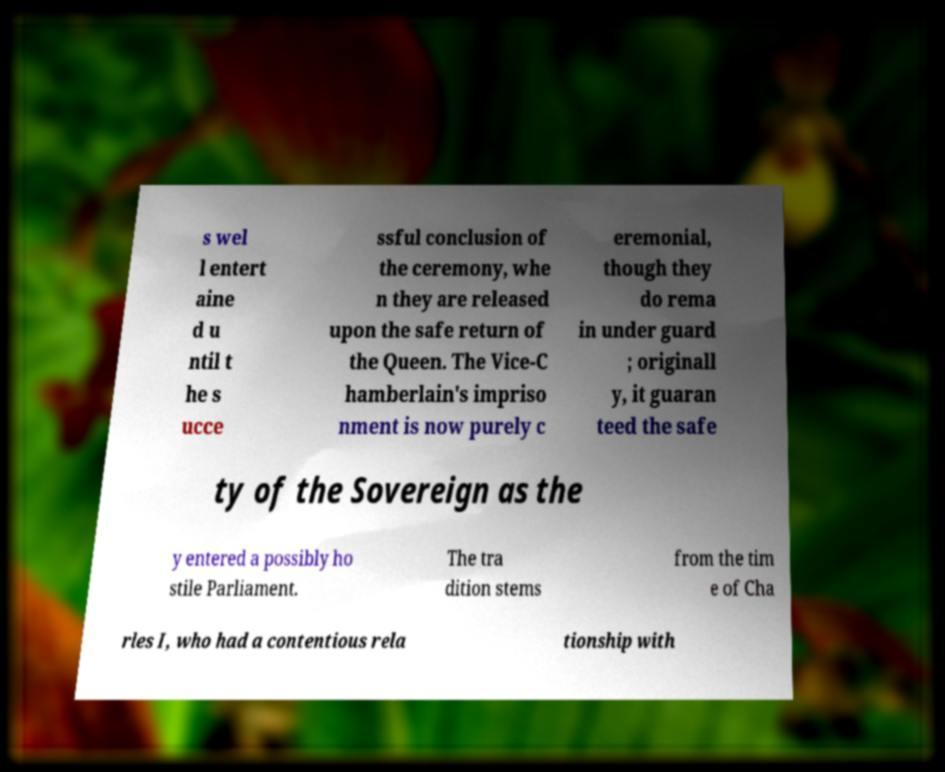What messages or text are displayed in this image? I need them in a readable, typed format. s wel l entert aine d u ntil t he s ucce ssful conclusion of the ceremony, whe n they are released upon the safe return of the Queen. The Vice-C hamberlain's impriso nment is now purely c eremonial, though they do rema in under guard ; originall y, it guaran teed the safe ty of the Sovereign as the y entered a possibly ho stile Parliament. The tra dition stems from the tim e of Cha rles I, who had a contentious rela tionship with 